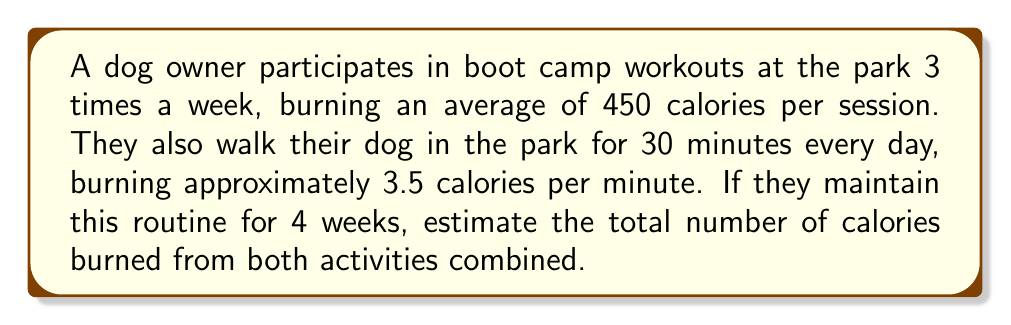Solve this math problem. To solve this problem, let's break it down into steps:

1. Calculate calories burned from boot camp workouts:
   - Sessions per week: 3
   - Calories burned per session: 450
   - Number of weeks: 4
   
   Total calories from boot camp = $3 \times 450 \times 4 = 5400$ calories

2. Calculate calories burned from dog walking:
   - Minutes walked per day: 30
   - Calories burned per minute: 3.5
   - Number of days in 4 weeks: $4 \times 7 = 28$
   
   Total calories from dog walking = $30 \times 3.5 \times 28 = 2940$ calories

3. Sum up the total calories burned:
   Total calories = Calories from boot camp + Calories from dog walking
   
   $$ \text{Total calories} = 5400 + 2940 = 8340 \text{ calories} $$

Therefore, the estimated total number of calories burned from both activities combined over 4 weeks is 8340 calories.
Answer: 8340 calories 